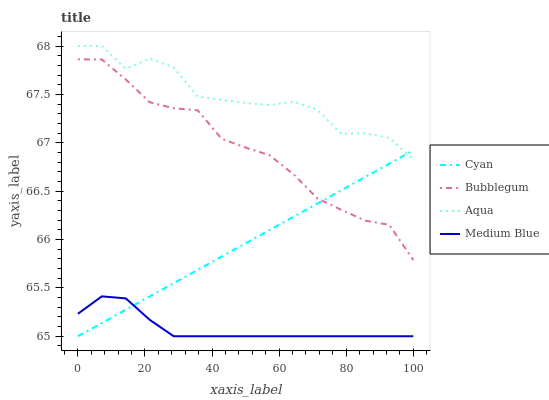Does Medium Blue have the minimum area under the curve?
Answer yes or no. Yes. Does Aqua have the maximum area under the curve?
Answer yes or no. Yes. Does Aqua have the minimum area under the curve?
Answer yes or no. No. Does Medium Blue have the maximum area under the curve?
Answer yes or no. No. Is Cyan the smoothest?
Answer yes or no. Yes. Is Aqua the roughest?
Answer yes or no. Yes. Is Medium Blue the smoothest?
Answer yes or no. No. Is Medium Blue the roughest?
Answer yes or no. No. Does Cyan have the lowest value?
Answer yes or no. Yes. Does Aqua have the lowest value?
Answer yes or no. No. Does Aqua have the highest value?
Answer yes or no. Yes. Does Medium Blue have the highest value?
Answer yes or no. No. Is Medium Blue less than Bubblegum?
Answer yes or no. Yes. Is Aqua greater than Medium Blue?
Answer yes or no. Yes. Does Bubblegum intersect Cyan?
Answer yes or no. Yes. Is Bubblegum less than Cyan?
Answer yes or no. No. Is Bubblegum greater than Cyan?
Answer yes or no. No. Does Medium Blue intersect Bubblegum?
Answer yes or no. No. 